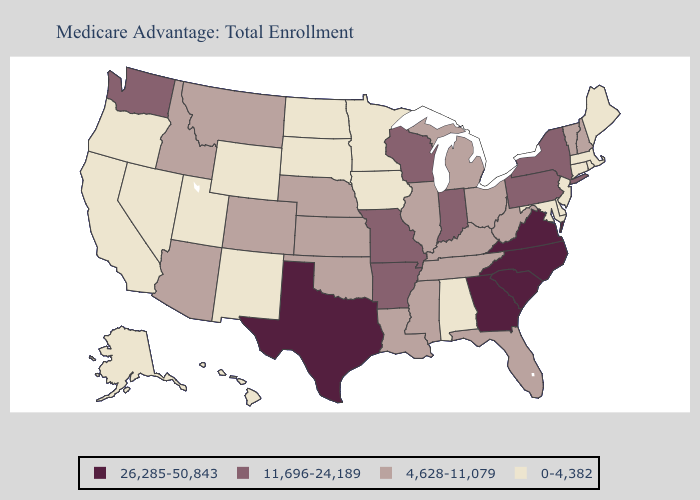Name the states that have a value in the range 26,285-50,843?
Quick response, please. Georgia, North Carolina, South Carolina, Texas, Virginia. Among the states that border Louisiana , does Texas have the lowest value?
Write a very short answer. No. Name the states that have a value in the range 26,285-50,843?
Quick response, please. Georgia, North Carolina, South Carolina, Texas, Virginia. Name the states that have a value in the range 0-4,382?
Quick response, please. Alaska, Alabama, California, Connecticut, Delaware, Hawaii, Iowa, Massachusetts, Maryland, Maine, Minnesota, North Dakota, New Jersey, New Mexico, Nevada, Oregon, Rhode Island, South Dakota, Utah, Wyoming. What is the highest value in states that border Arkansas?
Short answer required. 26,285-50,843. Name the states that have a value in the range 4,628-11,079?
Keep it brief. Arizona, Colorado, Florida, Idaho, Illinois, Kansas, Kentucky, Louisiana, Michigan, Mississippi, Montana, Nebraska, New Hampshire, Ohio, Oklahoma, Tennessee, Vermont, West Virginia. Does Georgia have the lowest value in the USA?
Answer briefly. No. Does Alaska have a higher value than Nebraska?
Concise answer only. No. Does South Carolina have the highest value in the South?
Write a very short answer. Yes. What is the value of Alaska?
Give a very brief answer. 0-4,382. Name the states that have a value in the range 26,285-50,843?
Keep it brief. Georgia, North Carolina, South Carolina, Texas, Virginia. Name the states that have a value in the range 0-4,382?
Write a very short answer. Alaska, Alabama, California, Connecticut, Delaware, Hawaii, Iowa, Massachusetts, Maryland, Maine, Minnesota, North Dakota, New Jersey, New Mexico, Nevada, Oregon, Rhode Island, South Dakota, Utah, Wyoming. Name the states that have a value in the range 11,696-24,189?
Short answer required. Arkansas, Indiana, Missouri, New York, Pennsylvania, Washington, Wisconsin. How many symbols are there in the legend?
Quick response, please. 4. What is the highest value in the USA?
Write a very short answer. 26,285-50,843. 